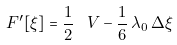<formula> <loc_0><loc_0><loc_500><loc_500>\ F ^ { \prime } [ \xi ] = \frac { 1 } { 2 } \, \ V - \frac { 1 } { 6 } \, \lambda _ { 0 } \, \Delta \xi</formula> 